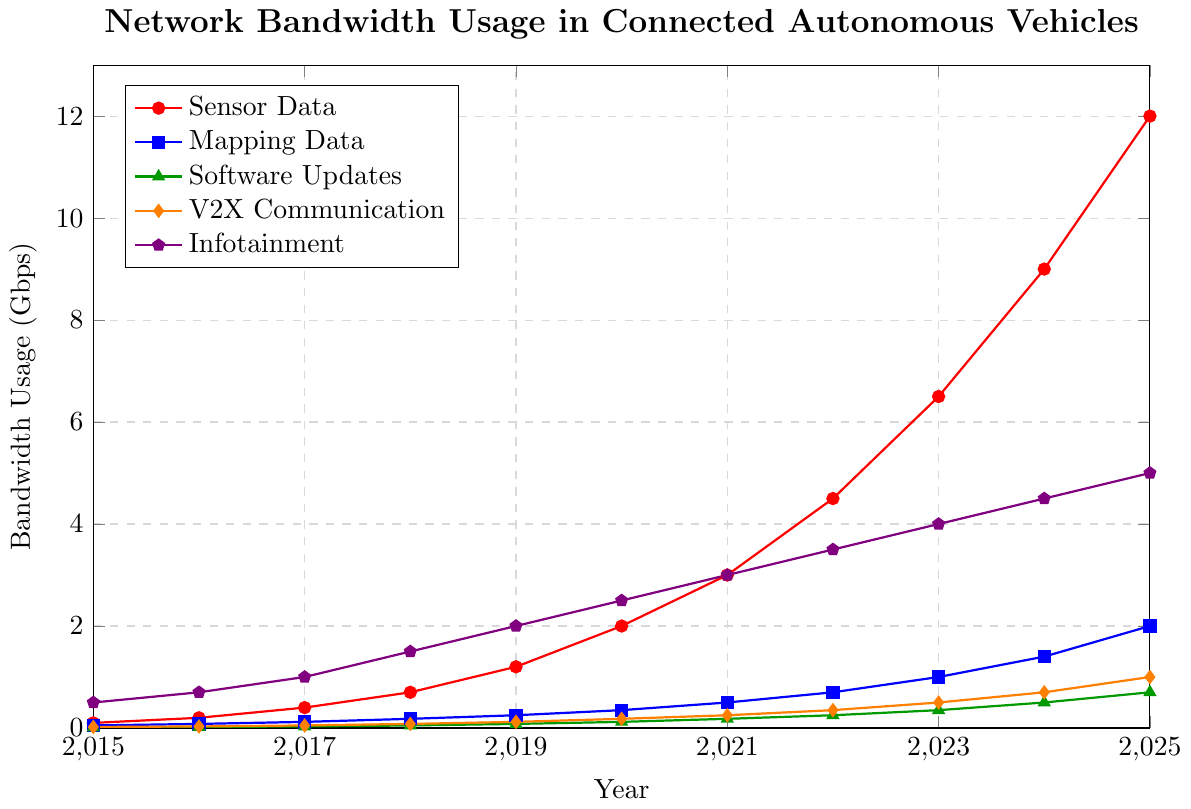Which year had the highest bandwidth usage for sensor data? The line representing sensor data shows a continuous increase over the years. The peak value appears in the final year on the x-axis. Checking that value shows the highest bandwidth usage.
Answer: 2025 In which year did infotainment bandwidth usage first reach 3 Gbps? Identify the infotainment data line, marked in violet. Trace this line visually to see at what year it first reaches 3 Gbps on the y-axis.
Answer: 2021 By how much did V2X communication bandwidth usage increase from 2015 to 2025? Locate the line for V2X communication (orange). Note the bandwidth values for 2015 and 2025 from the figure and then subtract the 2015 value from the 2025 value. (2025: 1.0 Gbps, 2015: 0.02 Gbps)
Answer: 0.98 Gbps What is the difference in sensor data bandwidth usage between 2020 and 2023? Find the sensor data values in 2020 and 2023 by tracing the relevant line (red). Subtract the 2020 value from the 2023 value. (2023: 6.5 Gbps, 2020: 2.0 Gbps)
Answer: 4.5 Gbps Which type of data saw the most significant overall increase in bandwidth usage from 2015 to 2025? Compare the changes in bandwidth usage for all types from 2015 to 2025 by visually inspecting the difference in their line endpoints. Sensor Data shows the largest increase.
Answer: Sensor Data What is the average bandwidth usage for mapping data over the 11 years? Sum all mapping data values for each year and divide by the number of years (11). (0.05+0.08+0.12+0.18+0.25+0.35+0.5+0.7+1.0+1.4+2.0) / 11
Answer: 0.62 Gbps During which year range did software updates bandwidth usage increase the most rapidly? Compute the difference between consecutive years for software updates, and identify the period with the greatest increase. The value seems to jump between 2023 and 2024, increasing from 0.35 to 0.5 Gbps.
Answer: 2023-2024 By how much did the total bandwidth usage (sum of all types) increase from 2015 to 2020? Calculate the total bandwidth usage for 2015 and 2020 by summing all types of data for these years, then find the difference. (2015 total: 0.68 Gbps, 2020 total: 5.15 Gbps)
Answer: 4.47 Gbps 